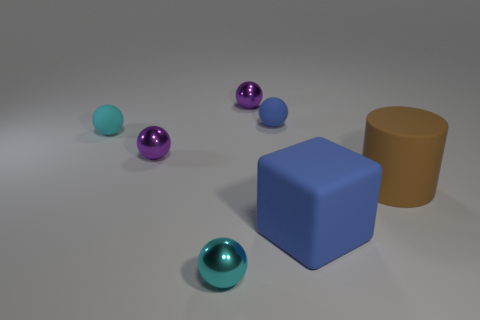What number of objects are both in front of the large cylinder and on the left side of the tiny blue rubber sphere? Upon analyzing the image, we can see that there is one purple rubber sphere that fulfills both conditions of being in front of the large cylinder and to the left of the tiny blue rubber sphere when viewing the scene from the current perspective. 